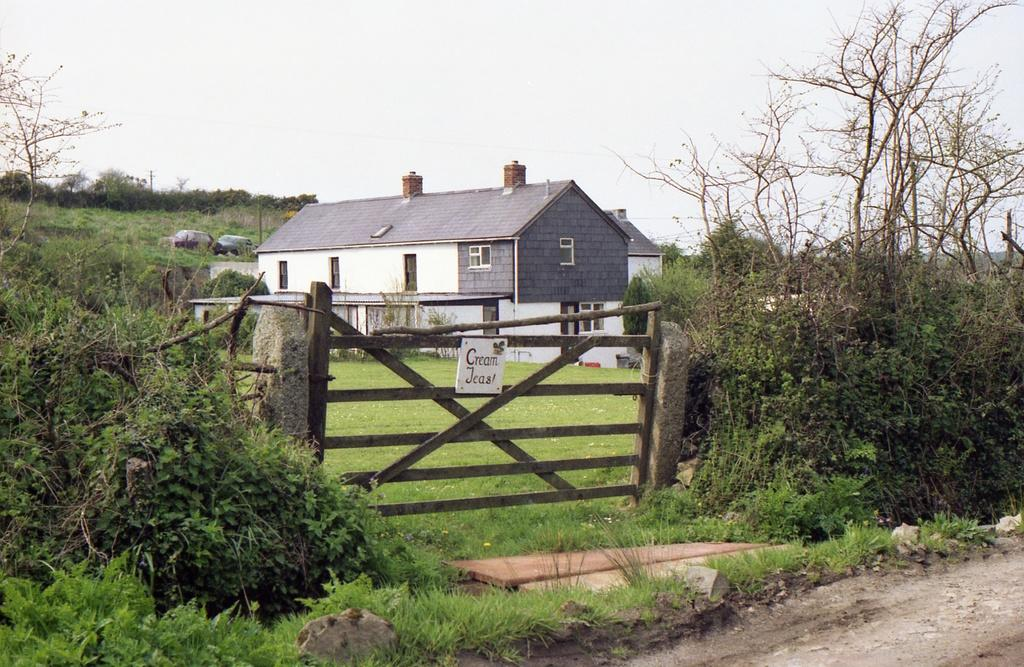What type of vegetation can be seen in the image? There are trees in the image. What is the ground covered with in the image? There is grass in the image. What type of structures are visible in the image? There are houses in the image. What can be seen in the distance in the image? In the background of the image, there are cars. What is the end of the fear that the drop in the image represents? There is no fear or drop present in the image; it features trees, grass, houses, and cars. 